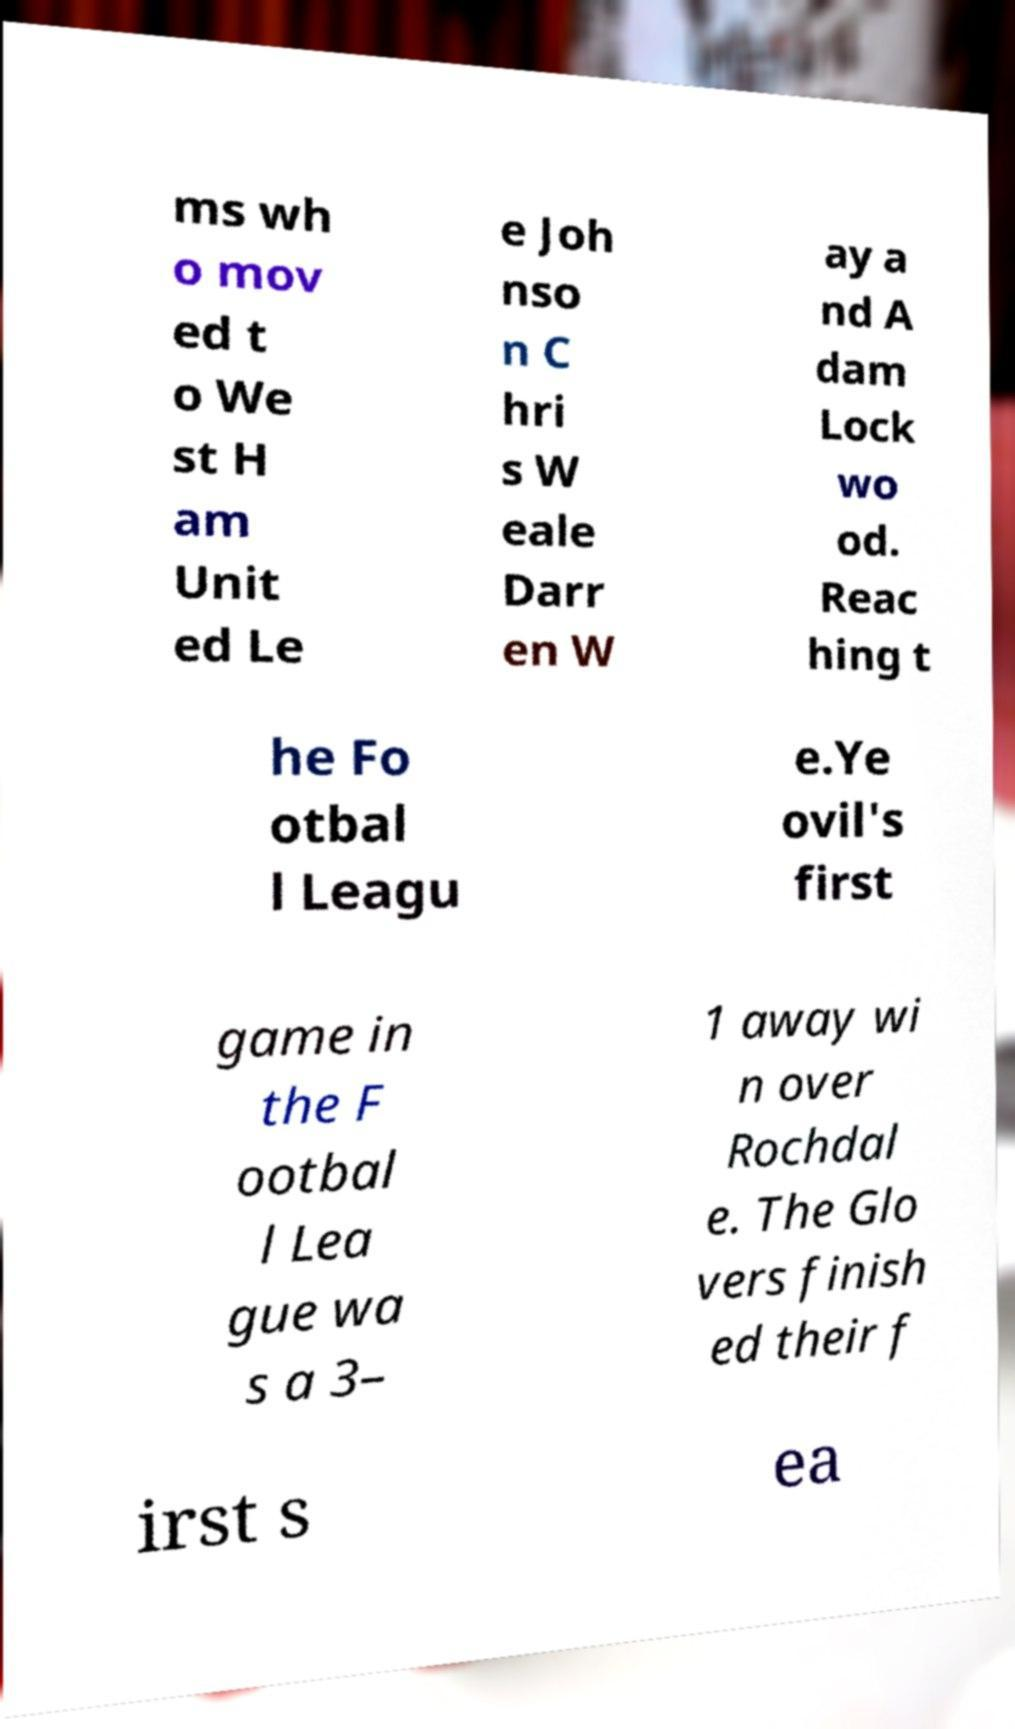For documentation purposes, I need the text within this image transcribed. Could you provide that? ms wh o mov ed t o We st H am Unit ed Le e Joh nso n C hri s W eale Darr en W ay a nd A dam Lock wo od. Reac hing t he Fo otbal l Leagu e.Ye ovil's first game in the F ootbal l Lea gue wa s a 3– 1 away wi n over Rochdal e. The Glo vers finish ed their f irst s ea 